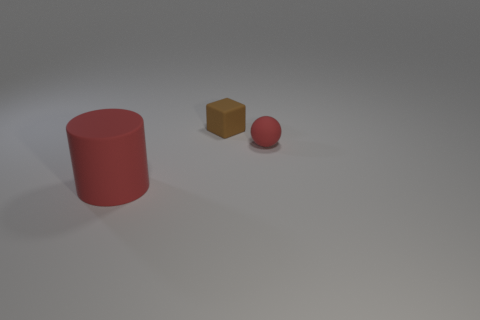Add 2 small cubes. How many objects exist? 5 Subtract all green metal spheres. Subtract all big matte objects. How many objects are left? 2 Add 3 brown matte objects. How many brown matte objects are left? 4 Add 2 rubber spheres. How many rubber spheres exist? 3 Subtract 0 yellow cubes. How many objects are left? 3 Subtract all cylinders. How many objects are left? 2 